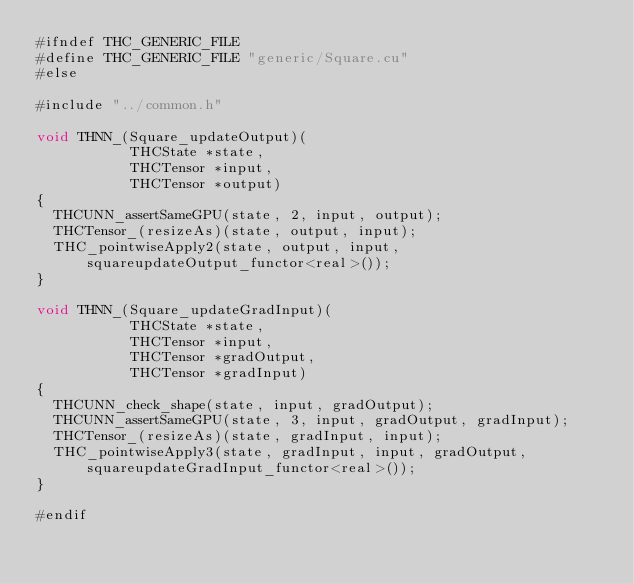Convert code to text. <code><loc_0><loc_0><loc_500><loc_500><_Cuda_>#ifndef THC_GENERIC_FILE
#define THC_GENERIC_FILE "generic/Square.cu"
#else

#include "../common.h"

void THNN_(Square_updateOutput)(
           THCState *state,
           THCTensor *input,
           THCTensor *output)
{
  THCUNN_assertSameGPU(state, 2, input, output);
  THCTensor_(resizeAs)(state, output, input);
  THC_pointwiseApply2(state, output, input, squareupdateOutput_functor<real>());
}

void THNN_(Square_updateGradInput)(
           THCState *state,
           THCTensor *input,
           THCTensor *gradOutput,
           THCTensor *gradInput)
{
  THCUNN_check_shape(state, input, gradOutput);
  THCUNN_assertSameGPU(state, 3, input, gradOutput, gradInput);
  THCTensor_(resizeAs)(state, gradInput, input);
  THC_pointwiseApply3(state, gradInput, input, gradOutput, squareupdateGradInput_functor<real>());
}

#endif
</code> 